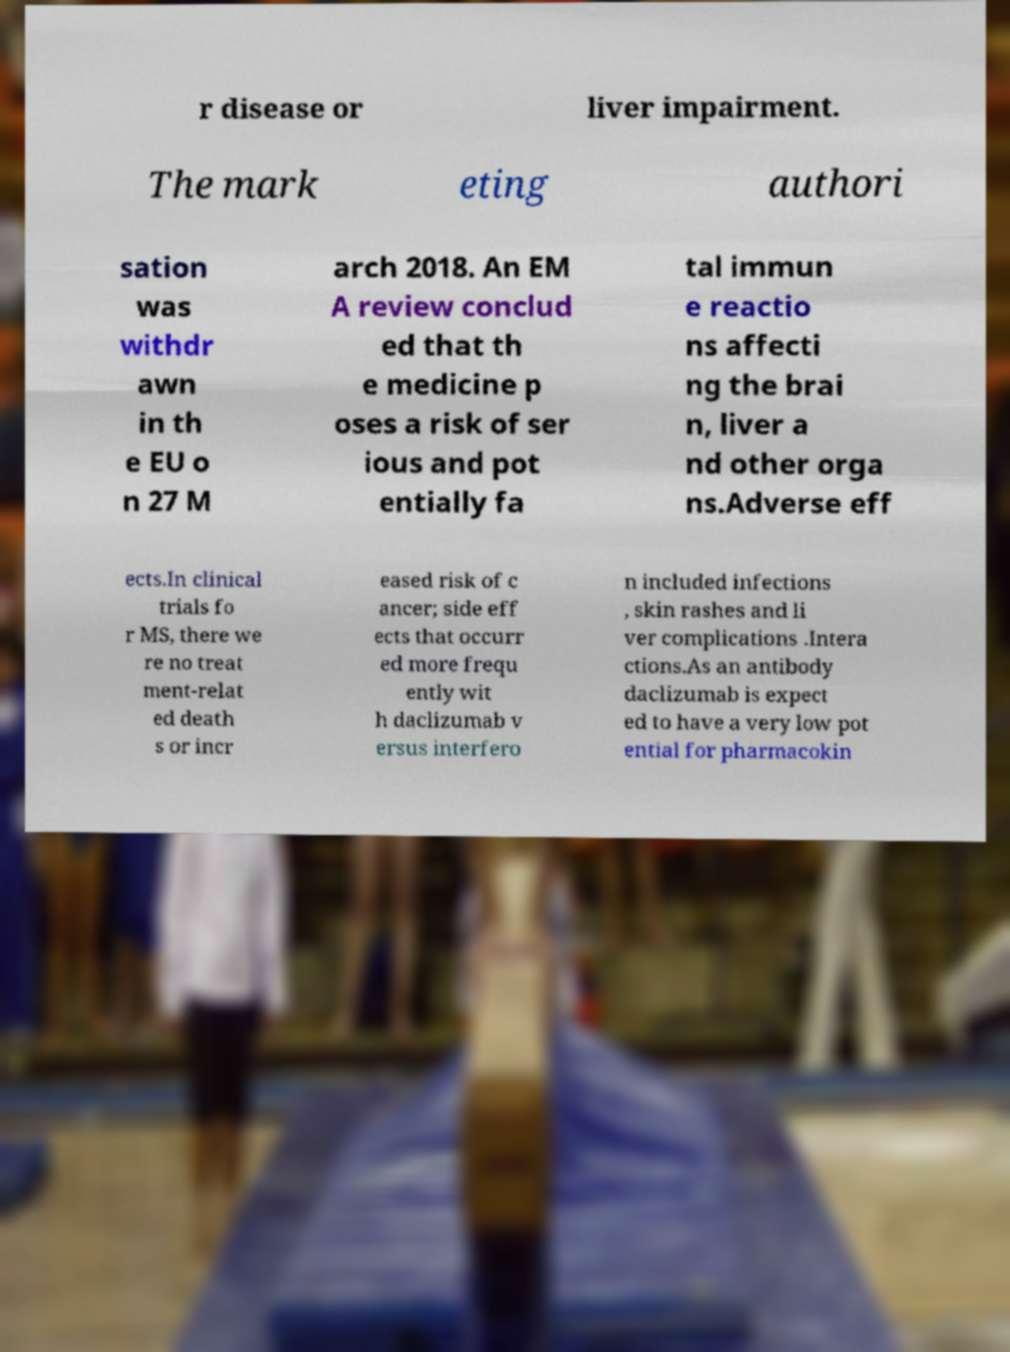There's text embedded in this image that I need extracted. Can you transcribe it verbatim? r disease or liver impairment. The mark eting authori sation was withdr awn in th e EU o n 27 M arch 2018. An EM A review conclud ed that th e medicine p oses a risk of ser ious and pot entially fa tal immun e reactio ns affecti ng the brai n, liver a nd other orga ns.Adverse eff ects.In clinical trials fo r MS, there we re no treat ment-relat ed death s or incr eased risk of c ancer; side eff ects that occurr ed more frequ ently wit h daclizumab v ersus interfero n included infections , skin rashes and li ver complications .Intera ctions.As an antibody daclizumab is expect ed to have a very low pot ential for pharmacokin 